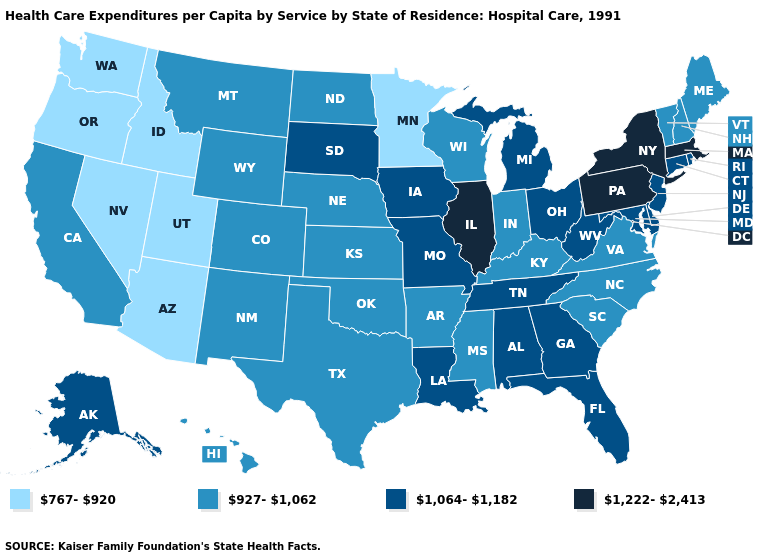What is the lowest value in states that border Florida?
Answer briefly. 1,064-1,182. What is the lowest value in the South?
Short answer required. 927-1,062. Which states have the lowest value in the USA?
Give a very brief answer. Arizona, Idaho, Minnesota, Nevada, Oregon, Utah, Washington. Does Rhode Island have the highest value in the Northeast?
Give a very brief answer. No. Is the legend a continuous bar?
Be succinct. No. What is the value of New Hampshire?
Be succinct. 927-1,062. Does the map have missing data?
Answer briefly. No. Does Hawaii have a higher value than Texas?
Write a very short answer. No. Among the states that border New Hampshire , does Vermont have the highest value?
Concise answer only. No. Does New York have the highest value in the USA?
Concise answer only. Yes. What is the value of Rhode Island?
Answer briefly. 1,064-1,182. Does the first symbol in the legend represent the smallest category?
Answer briefly. Yes. What is the highest value in the MidWest ?
Concise answer only. 1,222-2,413. What is the value of Iowa?
Answer briefly. 1,064-1,182. What is the highest value in the USA?
Quick response, please. 1,222-2,413. 